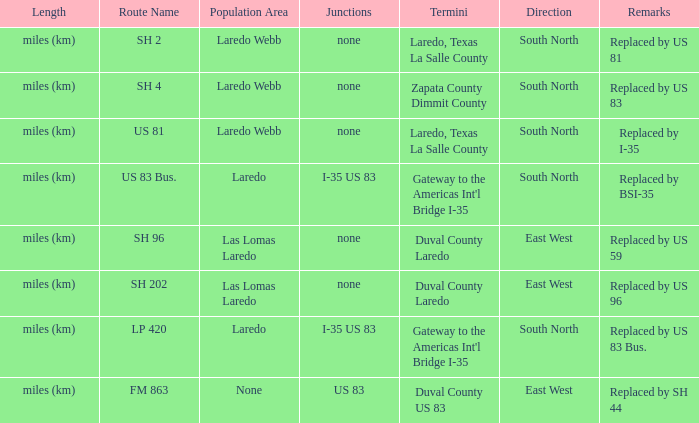Which population areas have "replaced by us 83" listed in their remarks section? Laredo Webb. 